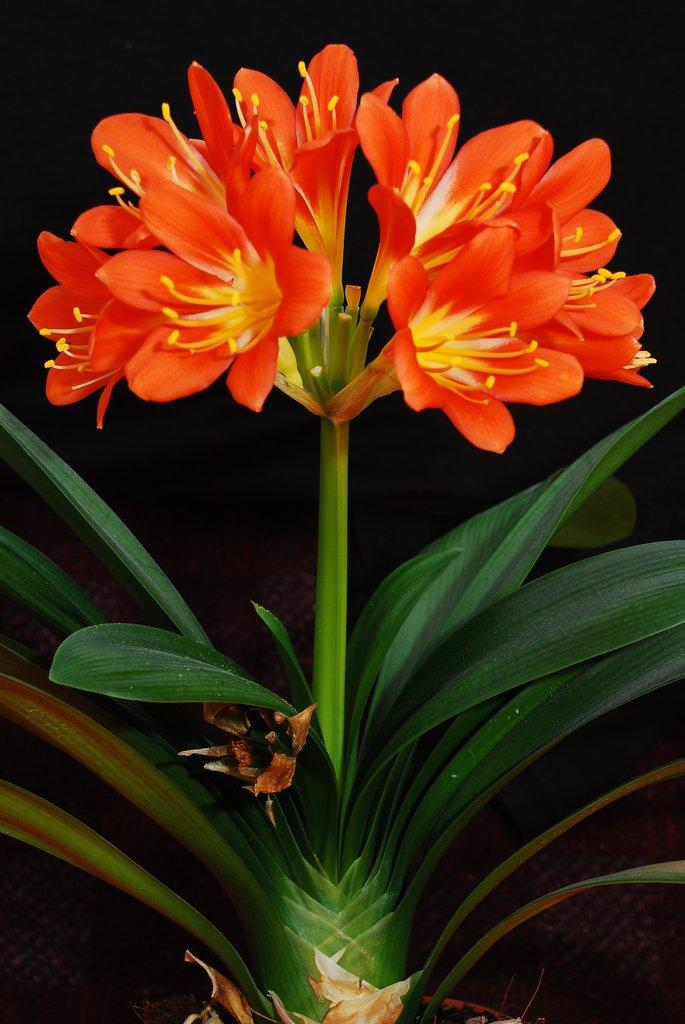What type of plant elements can be seen in the image? The image contains flowers and leaves of a plant. What specific part of the flowers is visible in the image? Petals are visible in the image. What substance is present on the flowers in the image? Pollen grains are present in the image. How would you describe the overall lighting in the image? The background of the image is dark. How many kittens can be seen playing with a brush in the image? There are no kittens or brushes present in the image; it features flowers and leaves of a plant. 